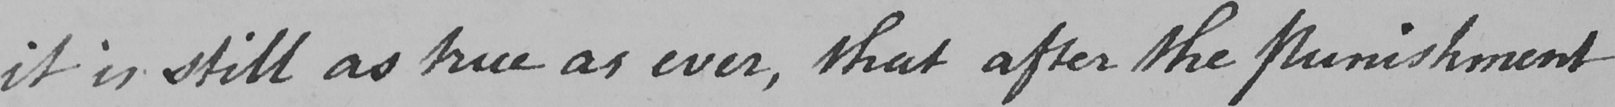Please transcribe the handwritten text in this image. it is still as true as ever , that after the punishment 